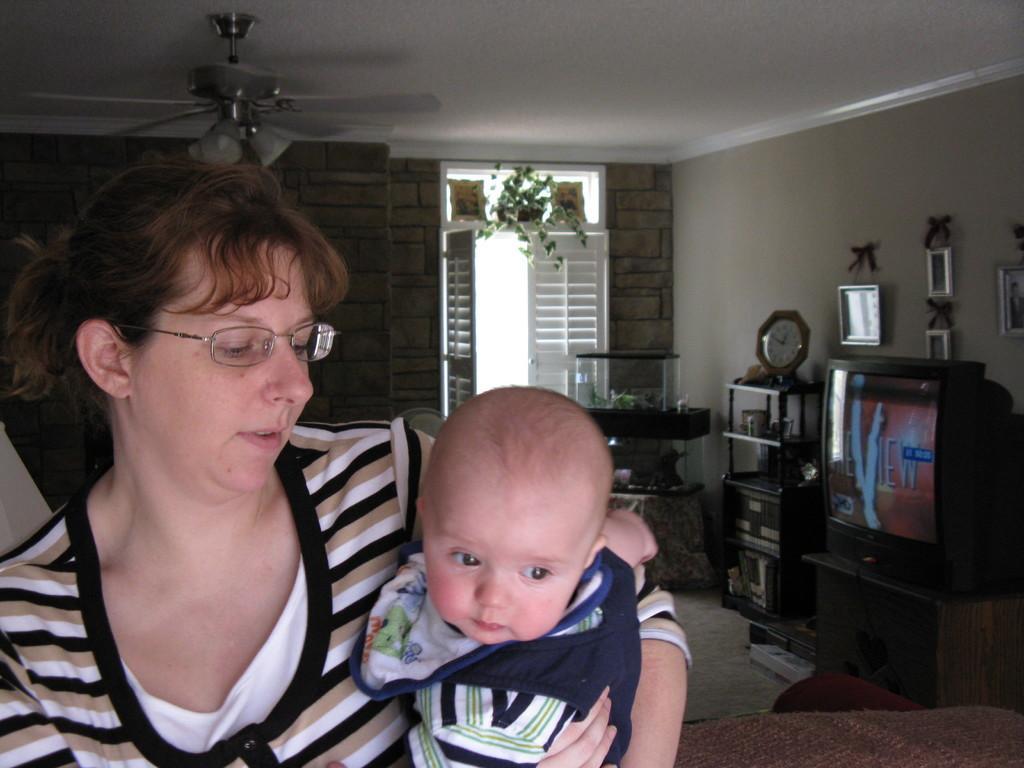Please provide a concise description of this image. In this picture there is a woman holding a baby and we can see floor, television on the stand, clock and objects in racks, frames on the wall and aquarium. In the background of the image we can see door, fan and houseplant. 